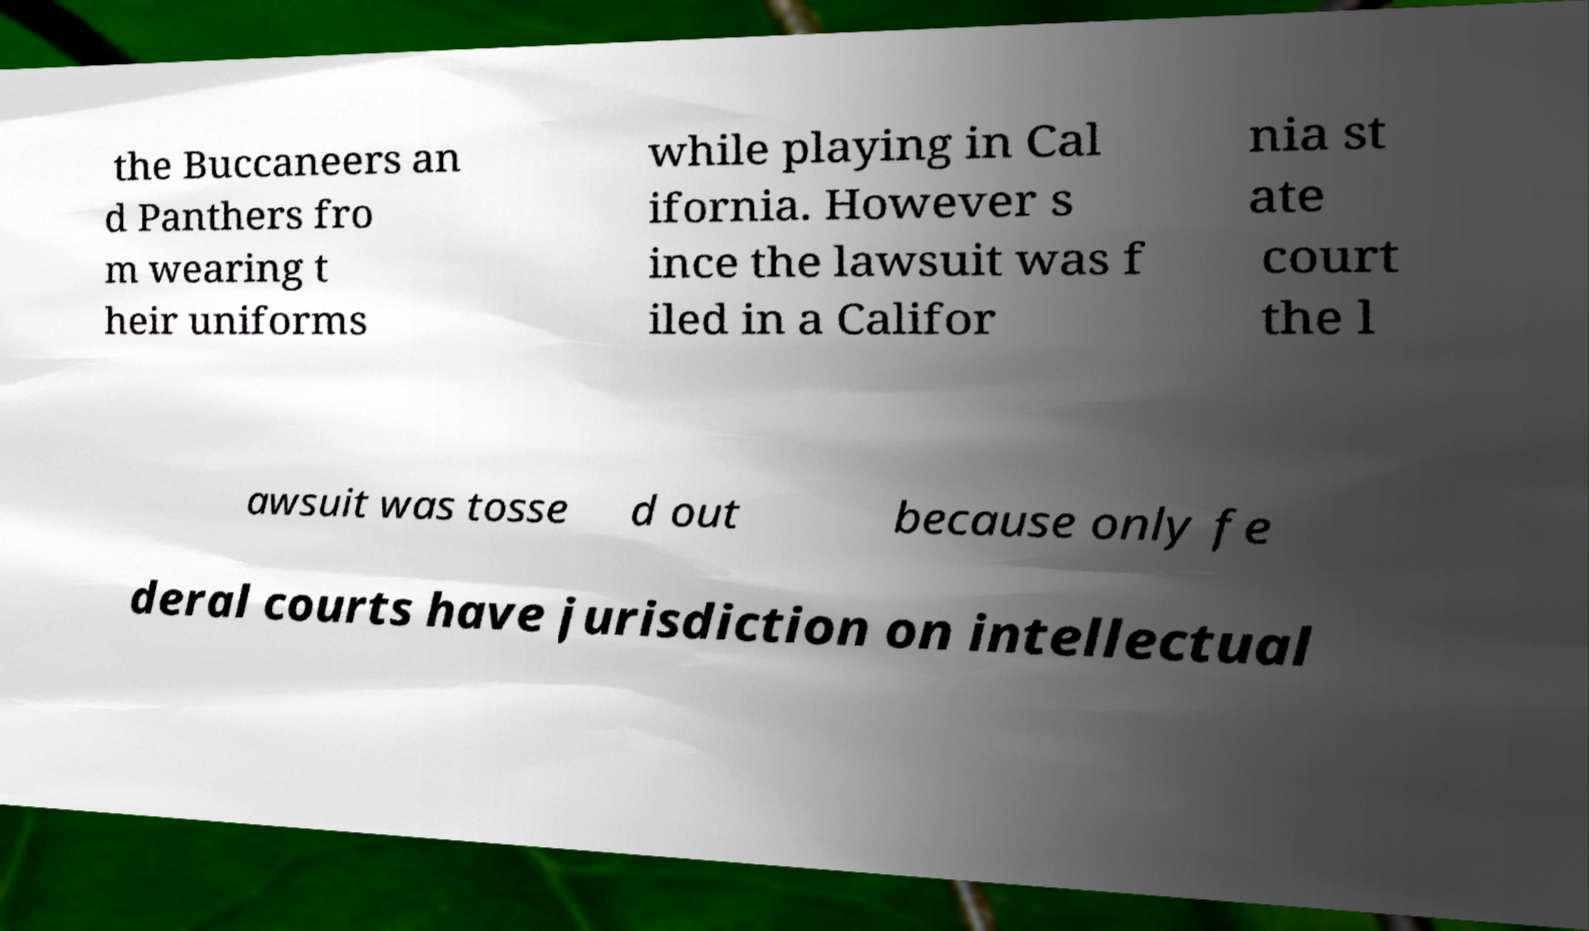There's text embedded in this image that I need extracted. Can you transcribe it verbatim? the Buccaneers an d Panthers fro m wearing t heir uniforms while playing in Cal ifornia. However s ince the lawsuit was f iled in a Califor nia st ate court the l awsuit was tosse d out because only fe deral courts have jurisdiction on intellectual 